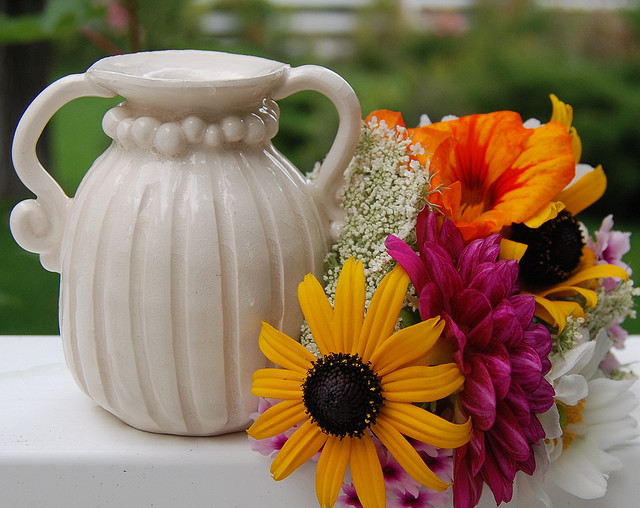<image>Is there tea in the pot? There is no tea in the pot. Is there tea in the pot? There is no tea in the pot. 